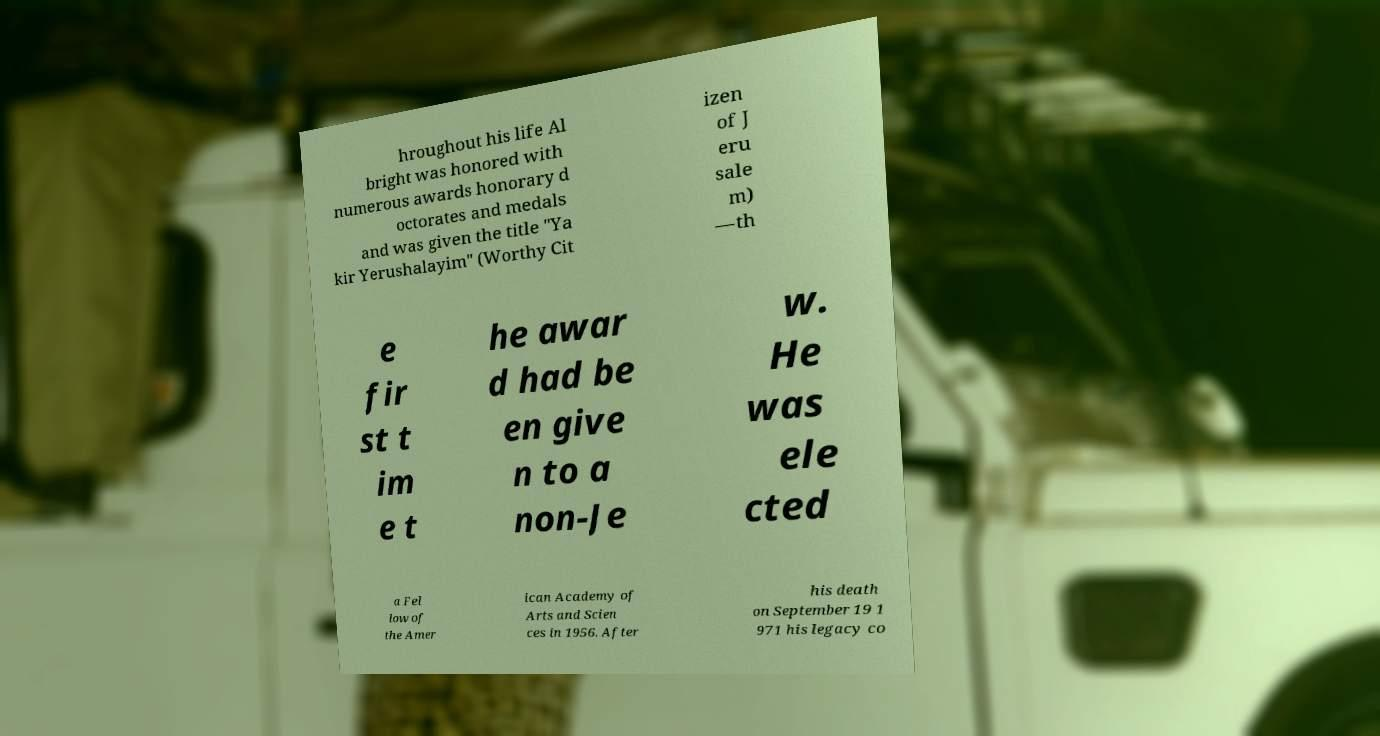Please read and relay the text visible in this image. What does it say? hroughout his life Al bright was honored with numerous awards honorary d octorates and medals and was given the title "Ya kir Yerushalayim" (Worthy Cit izen of J eru sale m) —th e fir st t im e t he awar d had be en give n to a non-Je w. He was ele cted a Fel low of the Amer ican Academy of Arts and Scien ces in 1956. After his death on September 19 1 971 his legacy co 